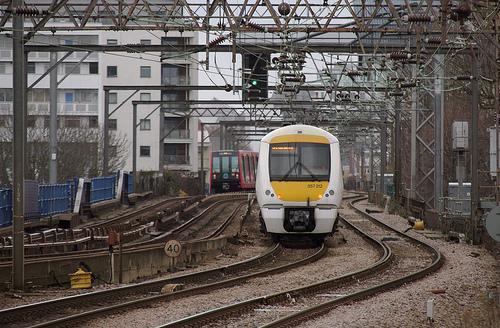How many trains are in this picture?
Give a very brief answer. 2. How many green lights are in this picture?
Give a very brief answer. 1. 